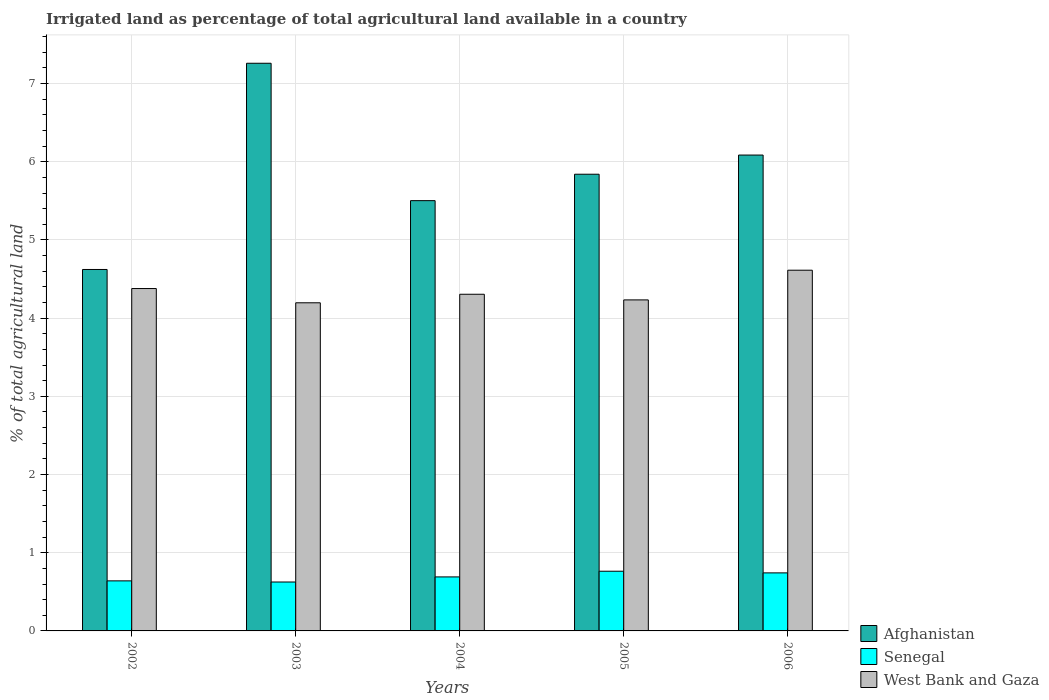How many different coloured bars are there?
Your response must be concise. 3. How many groups of bars are there?
Keep it short and to the point. 5. Are the number of bars per tick equal to the number of legend labels?
Your answer should be compact. Yes. What is the label of the 1st group of bars from the left?
Your answer should be compact. 2002. In how many cases, is the number of bars for a given year not equal to the number of legend labels?
Offer a terse response. 0. What is the percentage of irrigated land in Senegal in 2005?
Offer a very short reply. 0.76. Across all years, what is the maximum percentage of irrigated land in West Bank and Gaza?
Offer a very short reply. 4.61. Across all years, what is the minimum percentage of irrigated land in Senegal?
Your response must be concise. 0.63. In which year was the percentage of irrigated land in Afghanistan minimum?
Give a very brief answer. 2002. What is the total percentage of irrigated land in Afghanistan in the graph?
Make the answer very short. 29.31. What is the difference between the percentage of irrigated land in Senegal in 2003 and that in 2006?
Keep it short and to the point. -0.12. What is the difference between the percentage of irrigated land in Senegal in 2002 and the percentage of irrigated land in West Bank and Gaza in 2004?
Provide a succinct answer. -3.67. What is the average percentage of irrigated land in Senegal per year?
Provide a succinct answer. 0.69. In the year 2005, what is the difference between the percentage of irrigated land in Senegal and percentage of irrigated land in Afghanistan?
Give a very brief answer. -5.08. What is the ratio of the percentage of irrigated land in Afghanistan in 2003 to that in 2006?
Make the answer very short. 1.19. Is the percentage of irrigated land in Afghanistan in 2005 less than that in 2006?
Offer a terse response. Yes. Is the difference between the percentage of irrigated land in Senegal in 2005 and 2006 greater than the difference between the percentage of irrigated land in Afghanistan in 2005 and 2006?
Your response must be concise. Yes. What is the difference between the highest and the second highest percentage of irrigated land in West Bank and Gaza?
Keep it short and to the point. 0.23. What is the difference between the highest and the lowest percentage of irrigated land in West Bank and Gaza?
Offer a terse response. 0.42. In how many years, is the percentage of irrigated land in Senegal greater than the average percentage of irrigated land in Senegal taken over all years?
Make the answer very short. 2. What does the 1st bar from the left in 2004 represents?
Your answer should be very brief. Afghanistan. What does the 2nd bar from the right in 2002 represents?
Keep it short and to the point. Senegal. What is the difference between two consecutive major ticks on the Y-axis?
Ensure brevity in your answer.  1. Are the values on the major ticks of Y-axis written in scientific E-notation?
Offer a terse response. No. Does the graph contain any zero values?
Your response must be concise. No. Does the graph contain grids?
Your answer should be compact. Yes. Where does the legend appear in the graph?
Ensure brevity in your answer.  Bottom right. How many legend labels are there?
Ensure brevity in your answer.  3. What is the title of the graph?
Your answer should be compact. Irrigated land as percentage of total agricultural land available in a country. Does "Morocco" appear as one of the legend labels in the graph?
Give a very brief answer. No. What is the label or title of the X-axis?
Ensure brevity in your answer.  Years. What is the label or title of the Y-axis?
Give a very brief answer. % of total agricultural land. What is the % of total agricultural land in Afghanistan in 2002?
Your answer should be very brief. 4.62. What is the % of total agricultural land in Senegal in 2002?
Offer a very short reply. 0.64. What is the % of total agricultural land in West Bank and Gaza in 2002?
Your answer should be very brief. 4.38. What is the % of total agricultural land of Afghanistan in 2003?
Provide a succinct answer. 7.26. What is the % of total agricultural land in Senegal in 2003?
Your response must be concise. 0.63. What is the % of total agricultural land in West Bank and Gaza in 2003?
Ensure brevity in your answer.  4.2. What is the % of total agricultural land of Afghanistan in 2004?
Your answer should be very brief. 5.5. What is the % of total agricultural land in Senegal in 2004?
Offer a very short reply. 0.69. What is the % of total agricultural land of West Bank and Gaza in 2004?
Ensure brevity in your answer.  4.31. What is the % of total agricultural land in Afghanistan in 2005?
Make the answer very short. 5.84. What is the % of total agricultural land in Senegal in 2005?
Your response must be concise. 0.76. What is the % of total agricultural land in West Bank and Gaza in 2005?
Make the answer very short. 4.23. What is the % of total agricultural land in Afghanistan in 2006?
Ensure brevity in your answer.  6.09. What is the % of total agricultural land of Senegal in 2006?
Provide a short and direct response. 0.74. What is the % of total agricultural land of West Bank and Gaza in 2006?
Your response must be concise. 4.61. Across all years, what is the maximum % of total agricultural land of Afghanistan?
Your answer should be compact. 7.26. Across all years, what is the maximum % of total agricultural land in Senegal?
Make the answer very short. 0.76. Across all years, what is the maximum % of total agricultural land in West Bank and Gaza?
Your answer should be compact. 4.61. Across all years, what is the minimum % of total agricultural land in Afghanistan?
Provide a short and direct response. 4.62. Across all years, what is the minimum % of total agricultural land of Senegal?
Provide a short and direct response. 0.63. Across all years, what is the minimum % of total agricultural land in West Bank and Gaza?
Keep it short and to the point. 4.2. What is the total % of total agricultural land in Afghanistan in the graph?
Provide a short and direct response. 29.31. What is the total % of total agricultural land of Senegal in the graph?
Provide a short and direct response. 3.46. What is the total % of total agricultural land of West Bank and Gaza in the graph?
Offer a very short reply. 21.73. What is the difference between the % of total agricultural land in Afghanistan in 2002 and that in 2003?
Keep it short and to the point. -2.64. What is the difference between the % of total agricultural land in Senegal in 2002 and that in 2003?
Ensure brevity in your answer.  0.01. What is the difference between the % of total agricultural land in West Bank and Gaza in 2002 and that in 2003?
Offer a terse response. 0.18. What is the difference between the % of total agricultural land in Afghanistan in 2002 and that in 2004?
Make the answer very short. -0.88. What is the difference between the % of total agricultural land in Senegal in 2002 and that in 2004?
Give a very brief answer. -0.05. What is the difference between the % of total agricultural land of West Bank and Gaza in 2002 and that in 2004?
Your response must be concise. 0.07. What is the difference between the % of total agricultural land of Afghanistan in 2002 and that in 2005?
Your answer should be compact. -1.22. What is the difference between the % of total agricultural land in Senegal in 2002 and that in 2005?
Keep it short and to the point. -0.12. What is the difference between the % of total agricultural land in West Bank and Gaza in 2002 and that in 2005?
Make the answer very short. 0.15. What is the difference between the % of total agricultural land of Afghanistan in 2002 and that in 2006?
Your response must be concise. -1.46. What is the difference between the % of total agricultural land in Senegal in 2002 and that in 2006?
Ensure brevity in your answer.  -0.1. What is the difference between the % of total agricultural land in West Bank and Gaza in 2002 and that in 2006?
Your answer should be compact. -0.23. What is the difference between the % of total agricultural land in Afghanistan in 2003 and that in 2004?
Offer a very short reply. 1.76. What is the difference between the % of total agricultural land of Senegal in 2003 and that in 2004?
Provide a short and direct response. -0.07. What is the difference between the % of total agricultural land in West Bank and Gaza in 2003 and that in 2004?
Keep it short and to the point. -0.11. What is the difference between the % of total agricultural land in Afghanistan in 2003 and that in 2005?
Provide a short and direct response. 1.42. What is the difference between the % of total agricultural land in Senegal in 2003 and that in 2005?
Your answer should be compact. -0.14. What is the difference between the % of total agricultural land in West Bank and Gaza in 2003 and that in 2005?
Provide a short and direct response. -0.04. What is the difference between the % of total agricultural land of Afghanistan in 2003 and that in 2006?
Offer a very short reply. 1.17. What is the difference between the % of total agricultural land of Senegal in 2003 and that in 2006?
Your answer should be very brief. -0.12. What is the difference between the % of total agricultural land of West Bank and Gaza in 2003 and that in 2006?
Provide a short and direct response. -0.42. What is the difference between the % of total agricultural land of Afghanistan in 2004 and that in 2005?
Your answer should be very brief. -0.34. What is the difference between the % of total agricultural land of Senegal in 2004 and that in 2005?
Provide a succinct answer. -0.07. What is the difference between the % of total agricultural land in West Bank and Gaza in 2004 and that in 2005?
Give a very brief answer. 0.07. What is the difference between the % of total agricultural land of Afghanistan in 2004 and that in 2006?
Give a very brief answer. -0.58. What is the difference between the % of total agricultural land of Senegal in 2004 and that in 2006?
Provide a short and direct response. -0.05. What is the difference between the % of total agricultural land of West Bank and Gaza in 2004 and that in 2006?
Offer a terse response. -0.31. What is the difference between the % of total agricultural land in Afghanistan in 2005 and that in 2006?
Provide a succinct answer. -0.25. What is the difference between the % of total agricultural land of Senegal in 2005 and that in 2006?
Provide a succinct answer. 0.02. What is the difference between the % of total agricultural land of West Bank and Gaza in 2005 and that in 2006?
Offer a very short reply. -0.38. What is the difference between the % of total agricultural land of Afghanistan in 2002 and the % of total agricultural land of Senegal in 2003?
Give a very brief answer. 4. What is the difference between the % of total agricultural land of Afghanistan in 2002 and the % of total agricultural land of West Bank and Gaza in 2003?
Offer a very short reply. 0.43. What is the difference between the % of total agricultural land in Senegal in 2002 and the % of total agricultural land in West Bank and Gaza in 2003?
Make the answer very short. -3.56. What is the difference between the % of total agricultural land in Afghanistan in 2002 and the % of total agricultural land in Senegal in 2004?
Your answer should be very brief. 3.93. What is the difference between the % of total agricultural land of Afghanistan in 2002 and the % of total agricultural land of West Bank and Gaza in 2004?
Make the answer very short. 0.32. What is the difference between the % of total agricultural land in Senegal in 2002 and the % of total agricultural land in West Bank and Gaza in 2004?
Keep it short and to the point. -3.67. What is the difference between the % of total agricultural land of Afghanistan in 2002 and the % of total agricultural land of Senegal in 2005?
Offer a very short reply. 3.86. What is the difference between the % of total agricultural land of Afghanistan in 2002 and the % of total agricultural land of West Bank and Gaza in 2005?
Your answer should be compact. 0.39. What is the difference between the % of total agricultural land of Senegal in 2002 and the % of total agricultural land of West Bank and Gaza in 2005?
Your answer should be compact. -3.59. What is the difference between the % of total agricultural land in Afghanistan in 2002 and the % of total agricultural land in Senegal in 2006?
Provide a succinct answer. 3.88. What is the difference between the % of total agricultural land in Afghanistan in 2002 and the % of total agricultural land in West Bank and Gaza in 2006?
Keep it short and to the point. 0.01. What is the difference between the % of total agricultural land of Senegal in 2002 and the % of total agricultural land of West Bank and Gaza in 2006?
Provide a succinct answer. -3.97. What is the difference between the % of total agricultural land of Afghanistan in 2003 and the % of total agricultural land of Senegal in 2004?
Ensure brevity in your answer.  6.57. What is the difference between the % of total agricultural land of Afghanistan in 2003 and the % of total agricultural land of West Bank and Gaza in 2004?
Give a very brief answer. 2.95. What is the difference between the % of total agricultural land in Senegal in 2003 and the % of total agricultural land in West Bank and Gaza in 2004?
Ensure brevity in your answer.  -3.68. What is the difference between the % of total agricultural land in Afghanistan in 2003 and the % of total agricultural land in Senegal in 2005?
Offer a very short reply. 6.5. What is the difference between the % of total agricultural land of Afghanistan in 2003 and the % of total agricultural land of West Bank and Gaza in 2005?
Provide a short and direct response. 3.03. What is the difference between the % of total agricultural land of Senegal in 2003 and the % of total agricultural land of West Bank and Gaza in 2005?
Give a very brief answer. -3.61. What is the difference between the % of total agricultural land of Afghanistan in 2003 and the % of total agricultural land of Senegal in 2006?
Provide a succinct answer. 6.52. What is the difference between the % of total agricultural land in Afghanistan in 2003 and the % of total agricultural land in West Bank and Gaza in 2006?
Provide a short and direct response. 2.65. What is the difference between the % of total agricultural land of Senegal in 2003 and the % of total agricultural land of West Bank and Gaza in 2006?
Ensure brevity in your answer.  -3.99. What is the difference between the % of total agricultural land of Afghanistan in 2004 and the % of total agricultural land of Senegal in 2005?
Your answer should be very brief. 4.74. What is the difference between the % of total agricultural land of Afghanistan in 2004 and the % of total agricultural land of West Bank and Gaza in 2005?
Offer a terse response. 1.27. What is the difference between the % of total agricultural land of Senegal in 2004 and the % of total agricultural land of West Bank and Gaza in 2005?
Ensure brevity in your answer.  -3.54. What is the difference between the % of total agricultural land of Afghanistan in 2004 and the % of total agricultural land of Senegal in 2006?
Your answer should be compact. 4.76. What is the difference between the % of total agricultural land of Afghanistan in 2004 and the % of total agricultural land of West Bank and Gaza in 2006?
Provide a succinct answer. 0.89. What is the difference between the % of total agricultural land of Senegal in 2004 and the % of total agricultural land of West Bank and Gaza in 2006?
Offer a very short reply. -3.92. What is the difference between the % of total agricultural land of Afghanistan in 2005 and the % of total agricultural land of Senegal in 2006?
Your answer should be compact. 5.1. What is the difference between the % of total agricultural land of Afghanistan in 2005 and the % of total agricultural land of West Bank and Gaza in 2006?
Ensure brevity in your answer.  1.23. What is the difference between the % of total agricultural land of Senegal in 2005 and the % of total agricultural land of West Bank and Gaza in 2006?
Your answer should be very brief. -3.85. What is the average % of total agricultural land in Afghanistan per year?
Offer a terse response. 5.86. What is the average % of total agricultural land of Senegal per year?
Ensure brevity in your answer.  0.69. What is the average % of total agricultural land in West Bank and Gaza per year?
Provide a short and direct response. 4.35. In the year 2002, what is the difference between the % of total agricultural land of Afghanistan and % of total agricultural land of Senegal?
Offer a very short reply. 3.98. In the year 2002, what is the difference between the % of total agricultural land of Afghanistan and % of total agricultural land of West Bank and Gaza?
Your answer should be compact. 0.24. In the year 2002, what is the difference between the % of total agricultural land in Senegal and % of total agricultural land in West Bank and Gaza?
Offer a very short reply. -3.74. In the year 2003, what is the difference between the % of total agricultural land in Afghanistan and % of total agricultural land in Senegal?
Give a very brief answer. 6.63. In the year 2003, what is the difference between the % of total agricultural land in Afghanistan and % of total agricultural land in West Bank and Gaza?
Offer a terse response. 3.06. In the year 2003, what is the difference between the % of total agricultural land in Senegal and % of total agricultural land in West Bank and Gaza?
Ensure brevity in your answer.  -3.57. In the year 2004, what is the difference between the % of total agricultural land in Afghanistan and % of total agricultural land in Senegal?
Your answer should be very brief. 4.81. In the year 2004, what is the difference between the % of total agricultural land in Afghanistan and % of total agricultural land in West Bank and Gaza?
Offer a very short reply. 1.2. In the year 2004, what is the difference between the % of total agricultural land in Senegal and % of total agricultural land in West Bank and Gaza?
Your response must be concise. -3.61. In the year 2005, what is the difference between the % of total agricultural land in Afghanistan and % of total agricultural land in Senegal?
Your response must be concise. 5.08. In the year 2005, what is the difference between the % of total agricultural land of Afghanistan and % of total agricultural land of West Bank and Gaza?
Your answer should be very brief. 1.61. In the year 2005, what is the difference between the % of total agricultural land in Senegal and % of total agricultural land in West Bank and Gaza?
Offer a terse response. -3.47. In the year 2006, what is the difference between the % of total agricultural land of Afghanistan and % of total agricultural land of Senegal?
Provide a succinct answer. 5.34. In the year 2006, what is the difference between the % of total agricultural land in Afghanistan and % of total agricultural land in West Bank and Gaza?
Make the answer very short. 1.47. In the year 2006, what is the difference between the % of total agricultural land in Senegal and % of total agricultural land in West Bank and Gaza?
Give a very brief answer. -3.87. What is the ratio of the % of total agricultural land in Afghanistan in 2002 to that in 2003?
Offer a very short reply. 0.64. What is the ratio of the % of total agricultural land in Senegal in 2002 to that in 2003?
Give a very brief answer. 1.02. What is the ratio of the % of total agricultural land of West Bank and Gaza in 2002 to that in 2003?
Your response must be concise. 1.04. What is the ratio of the % of total agricultural land in Afghanistan in 2002 to that in 2004?
Your response must be concise. 0.84. What is the ratio of the % of total agricultural land of Senegal in 2002 to that in 2004?
Provide a short and direct response. 0.93. What is the ratio of the % of total agricultural land of West Bank and Gaza in 2002 to that in 2004?
Offer a very short reply. 1.02. What is the ratio of the % of total agricultural land in Afghanistan in 2002 to that in 2005?
Offer a very short reply. 0.79. What is the ratio of the % of total agricultural land of Senegal in 2002 to that in 2005?
Keep it short and to the point. 0.84. What is the ratio of the % of total agricultural land in West Bank and Gaza in 2002 to that in 2005?
Ensure brevity in your answer.  1.03. What is the ratio of the % of total agricultural land in Afghanistan in 2002 to that in 2006?
Provide a short and direct response. 0.76. What is the ratio of the % of total agricultural land of Senegal in 2002 to that in 2006?
Keep it short and to the point. 0.86. What is the ratio of the % of total agricultural land in West Bank and Gaza in 2002 to that in 2006?
Ensure brevity in your answer.  0.95. What is the ratio of the % of total agricultural land of Afghanistan in 2003 to that in 2004?
Your answer should be very brief. 1.32. What is the ratio of the % of total agricultural land of Senegal in 2003 to that in 2004?
Make the answer very short. 0.91. What is the ratio of the % of total agricultural land of West Bank and Gaza in 2003 to that in 2004?
Offer a very short reply. 0.97. What is the ratio of the % of total agricultural land in Afghanistan in 2003 to that in 2005?
Your response must be concise. 1.24. What is the ratio of the % of total agricultural land in Senegal in 2003 to that in 2005?
Your answer should be very brief. 0.82. What is the ratio of the % of total agricultural land of West Bank and Gaza in 2003 to that in 2005?
Your answer should be compact. 0.99. What is the ratio of the % of total agricultural land in Afghanistan in 2003 to that in 2006?
Your response must be concise. 1.19. What is the ratio of the % of total agricultural land of Senegal in 2003 to that in 2006?
Give a very brief answer. 0.84. What is the ratio of the % of total agricultural land of West Bank and Gaza in 2003 to that in 2006?
Your answer should be very brief. 0.91. What is the ratio of the % of total agricultural land in Afghanistan in 2004 to that in 2005?
Offer a very short reply. 0.94. What is the ratio of the % of total agricultural land of Senegal in 2004 to that in 2005?
Ensure brevity in your answer.  0.9. What is the ratio of the % of total agricultural land of West Bank and Gaza in 2004 to that in 2005?
Keep it short and to the point. 1.02. What is the ratio of the % of total agricultural land of Afghanistan in 2004 to that in 2006?
Make the answer very short. 0.9. What is the ratio of the % of total agricultural land of Senegal in 2004 to that in 2006?
Provide a succinct answer. 0.93. What is the ratio of the % of total agricultural land in West Bank and Gaza in 2004 to that in 2006?
Provide a short and direct response. 0.93. What is the ratio of the % of total agricultural land of Afghanistan in 2005 to that in 2006?
Offer a terse response. 0.96. What is the ratio of the % of total agricultural land of Senegal in 2005 to that in 2006?
Provide a short and direct response. 1.03. What is the ratio of the % of total agricultural land of West Bank and Gaza in 2005 to that in 2006?
Your answer should be compact. 0.92. What is the difference between the highest and the second highest % of total agricultural land of Afghanistan?
Your answer should be very brief. 1.17. What is the difference between the highest and the second highest % of total agricultural land in Senegal?
Provide a short and direct response. 0.02. What is the difference between the highest and the second highest % of total agricultural land of West Bank and Gaza?
Your response must be concise. 0.23. What is the difference between the highest and the lowest % of total agricultural land of Afghanistan?
Provide a succinct answer. 2.64. What is the difference between the highest and the lowest % of total agricultural land in Senegal?
Offer a terse response. 0.14. What is the difference between the highest and the lowest % of total agricultural land in West Bank and Gaza?
Your response must be concise. 0.42. 